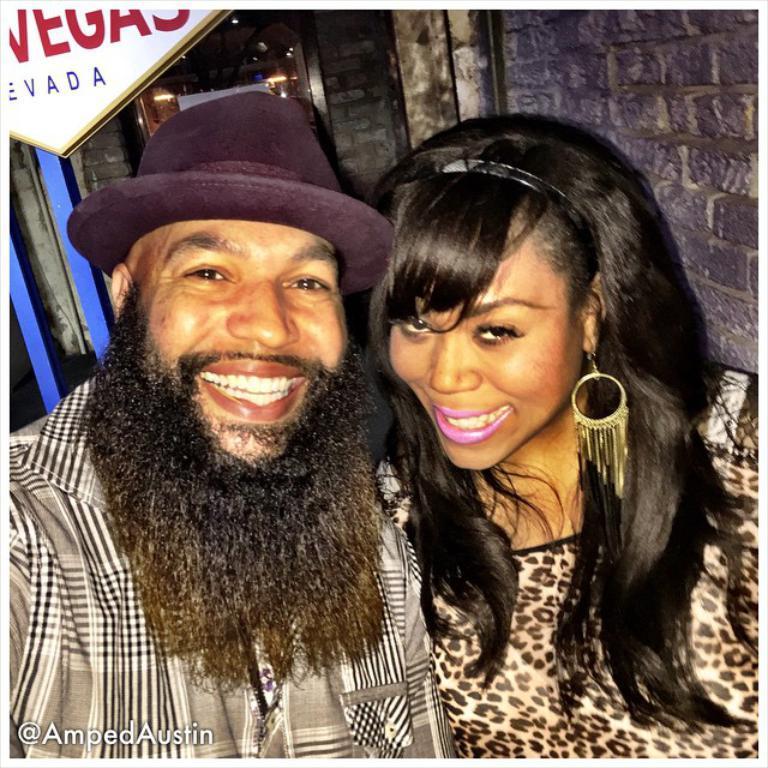In one or two sentences, can you explain what this image depicts? In this picture we can see the couple sitting in the front, smiling and giving a pose to the camera. In the background we can see the brick wall and notice board. 